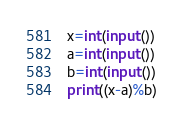<code> <loc_0><loc_0><loc_500><loc_500><_Python_>x=int(input())
a=int(input())
b=int(input())
print((x-a)%b)</code> 